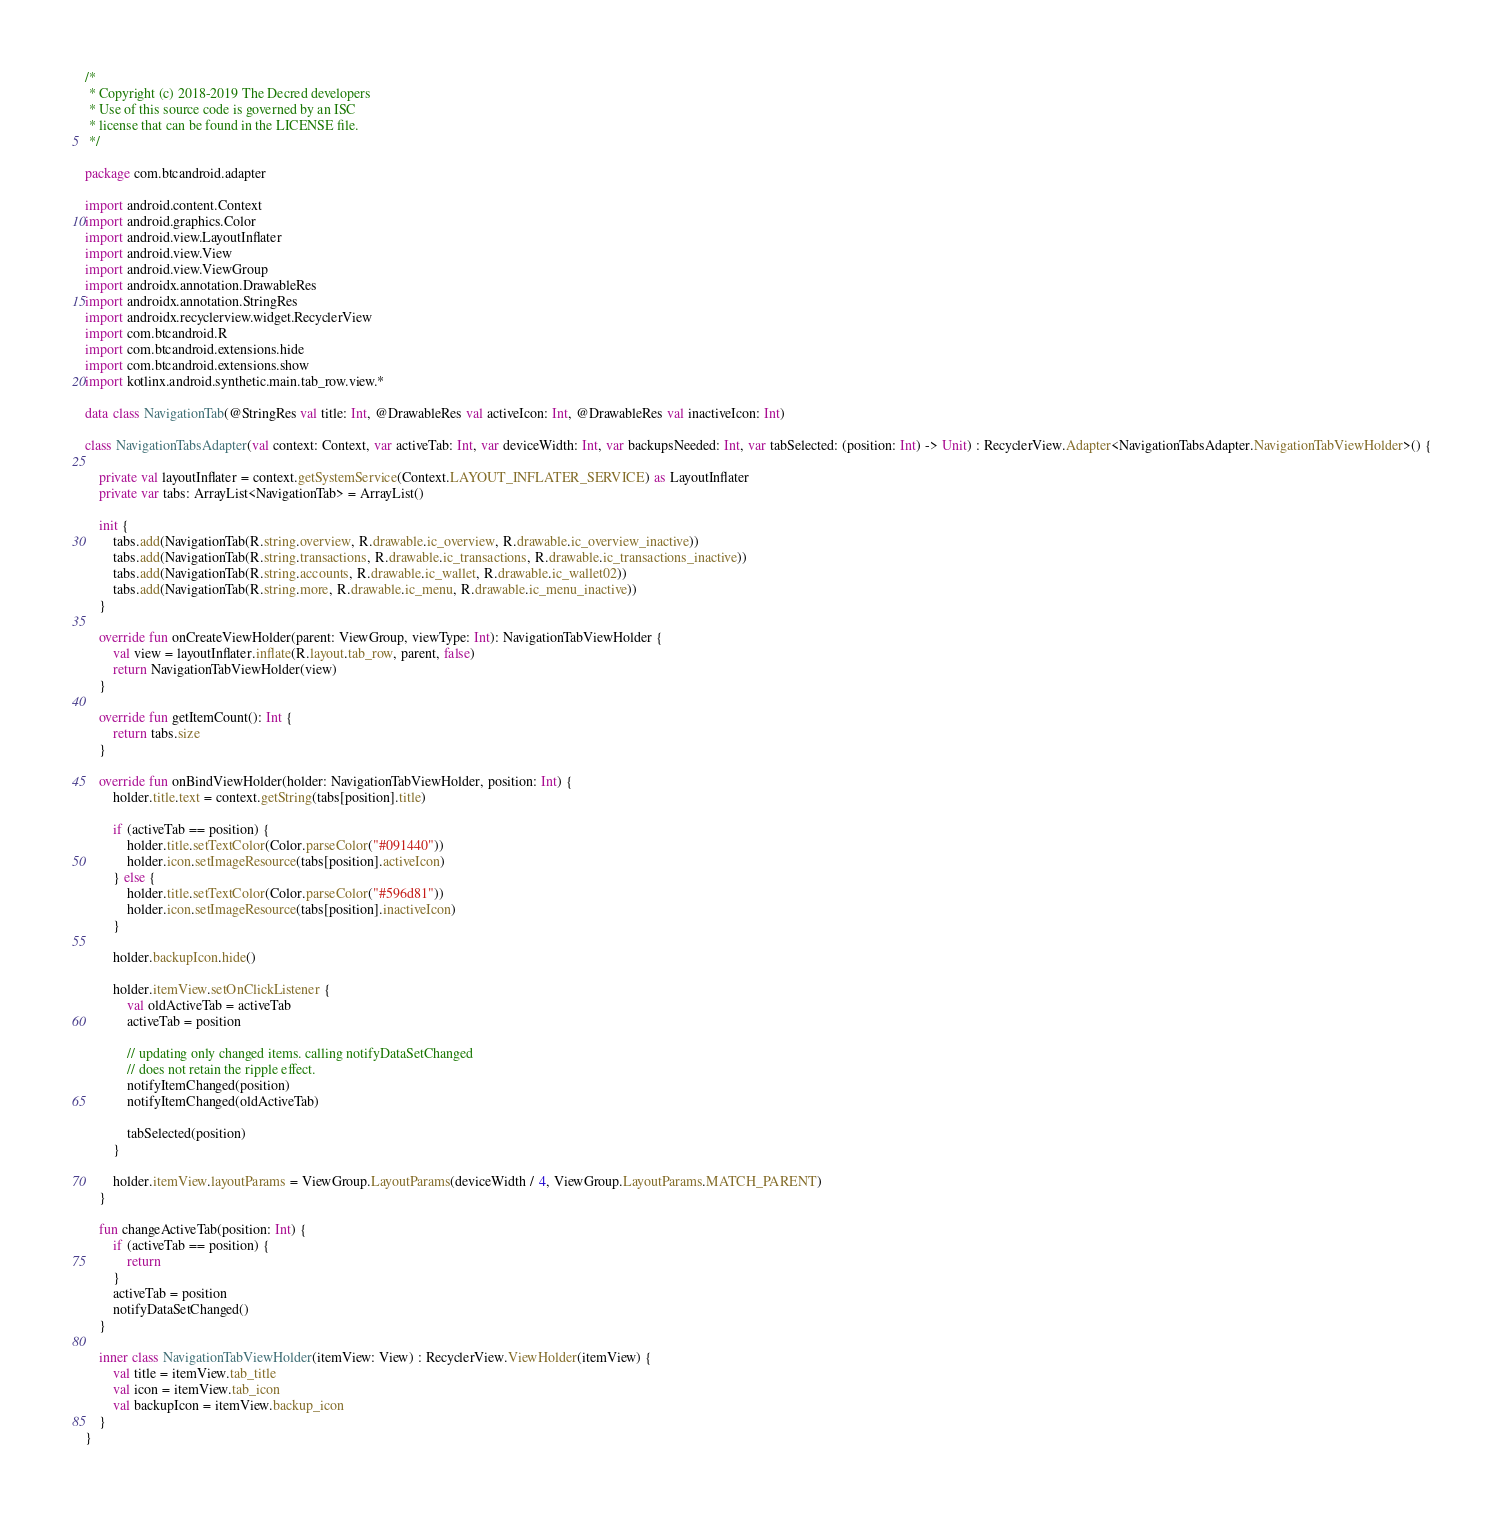Convert code to text. <code><loc_0><loc_0><loc_500><loc_500><_Kotlin_>/*
 * Copyright (c) 2018-2019 The Decred developers
 * Use of this source code is governed by an ISC
 * license that can be found in the LICENSE file.
 */

package com.btcandroid.adapter

import android.content.Context
import android.graphics.Color
import android.view.LayoutInflater
import android.view.View
import android.view.ViewGroup
import androidx.annotation.DrawableRes
import androidx.annotation.StringRes
import androidx.recyclerview.widget.RecyclerView
import com.btcandroid.R
import com.btcandroid.extensions.hide
import com.btcandroid.extensions.show
import kotlinx.android.synthetic.main.tab_row.view.*

data class NavigationTab(@StringRes val title: Int, @DrawableRes val activeIcon: Int, @DrawableRes val inactiveIcon: Int)

class NavigationTabsAdapter(val context: Context, var activeTab: Int, var deviceWidth: Int, var backupsNeeded: Int, var tabSelected: (position: Int) -> Unit) : RecyclerView.Adapter<NavigationTabsAdapter.NavigationTabViewHolder>() {

    private val layoutInflater = context.getSystemService(Context.LAYOUT_INFLATER_SERVICE) as LayoutInflater
    private var tabs: ArrayList<NavigationTab> = ArrayList()

    init {
        tabs.add(NavigationTab(R.string.overview, R.drawable.ic_overview, R.drawable.ic_overview_inactive))
        tabs.add(NavigationTab(R.string.transactions, R.drawable.ic_transactions, R.drawable.ic_transactions_inactive))
        tabs.add(NavigationTab(R.string.accounts, R.drawable.ic_wallet, R.drawable.ic_wallet02))
        tabs.add(NavigationTab(R.string.more, R.drawable.ic_menu, R.drawable.ic_menu_inactive))
    }

    override fun onCreateViewHolder(parent: ViewGroup, viewType: Int): NavigationTabViewHolder {
        val view = layoutInflater.inflate(R.layout.tab_row, parent, false)
        return NavigationTabViewHolder(view)
    }

    override fun getItemCount(): Int {
        return tabs.size
    }

    override fun onBindViewHolder(holder: NavigationTabViewHolder, position: Int) {
        holder.title.text = context.getString(tabs[position].title)

        if (activeTab == position) {
            holder.title.setTextColor(Color.parseColor("#091440"))
            holder.icon.setImageResource(tabs[position].activeIcon)
        } else {
            holder.title.setTextColor(Color.parseColor("#596d81"))
            holder.icon.setImageResource(tabs[position].inactiveIcon)
        }

        holder.backupIcon.hide()

        holder.itemView.setOnClickListener {
            val oldActiveTab = activeTab
            activeTab = position

            // updating only changed items. calling notifyDataSetChanged
            // does not retain the ripple effect.
            notifyItemChanged(position)
            notifyItemChanged(oldActiveTab)

            tabSelected(position)
        }

        holder.itemView.layoutParams = ViewGroup.LayoutParams(deviceWidth / 4, ViewGroup.LayoutParams.MATCH_PARENT)
    }

    fun changeActiveTab(position: Int) {
        if (activeTab == position) {
            return
        }
        activeTab = position
        notifyDataSetChanged()
    }

    inner class NavigationTabViewHolder(itemView: View) : RecyclerView.ViewHolder(itemView) {
        val title = itemView.tab_title
        val icon = itemView.tab_icon
        val backupIcon = itemView.backup_icon
    }
}</code> 